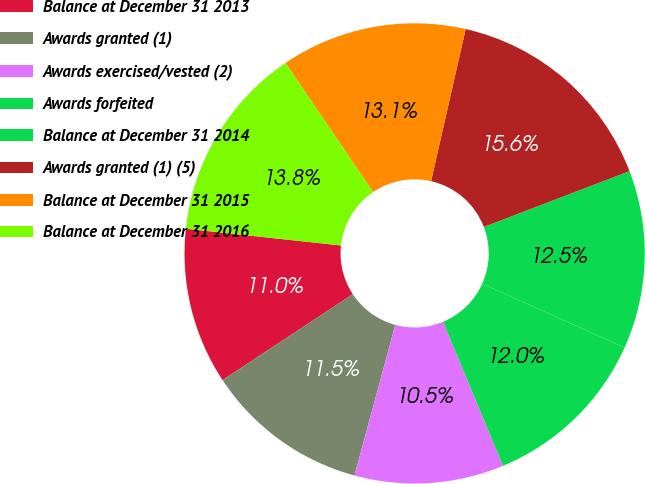Convert chart. <chart><loc_0><loc_0><loc_500><loc_500><pie_chart><fcel>Balance at December 31 2013<fcel>Awards granted (1)<fcel>Awards exercised/vested (2)<fcel>Awards forfeited<fcel>Balance at December 31 2014<fcel>Awards granted (1) (5)<fcel>Balance at December 31 2015<fcel>Balance at December 31 2016<nl><fcel>10.99%<fcel>11.51%<fcel>10.48%<fcel>12.02%<fcel>12.53%<fcel>15.62%<fcel>13.05%<fcel>13.8%<nl></chart> 